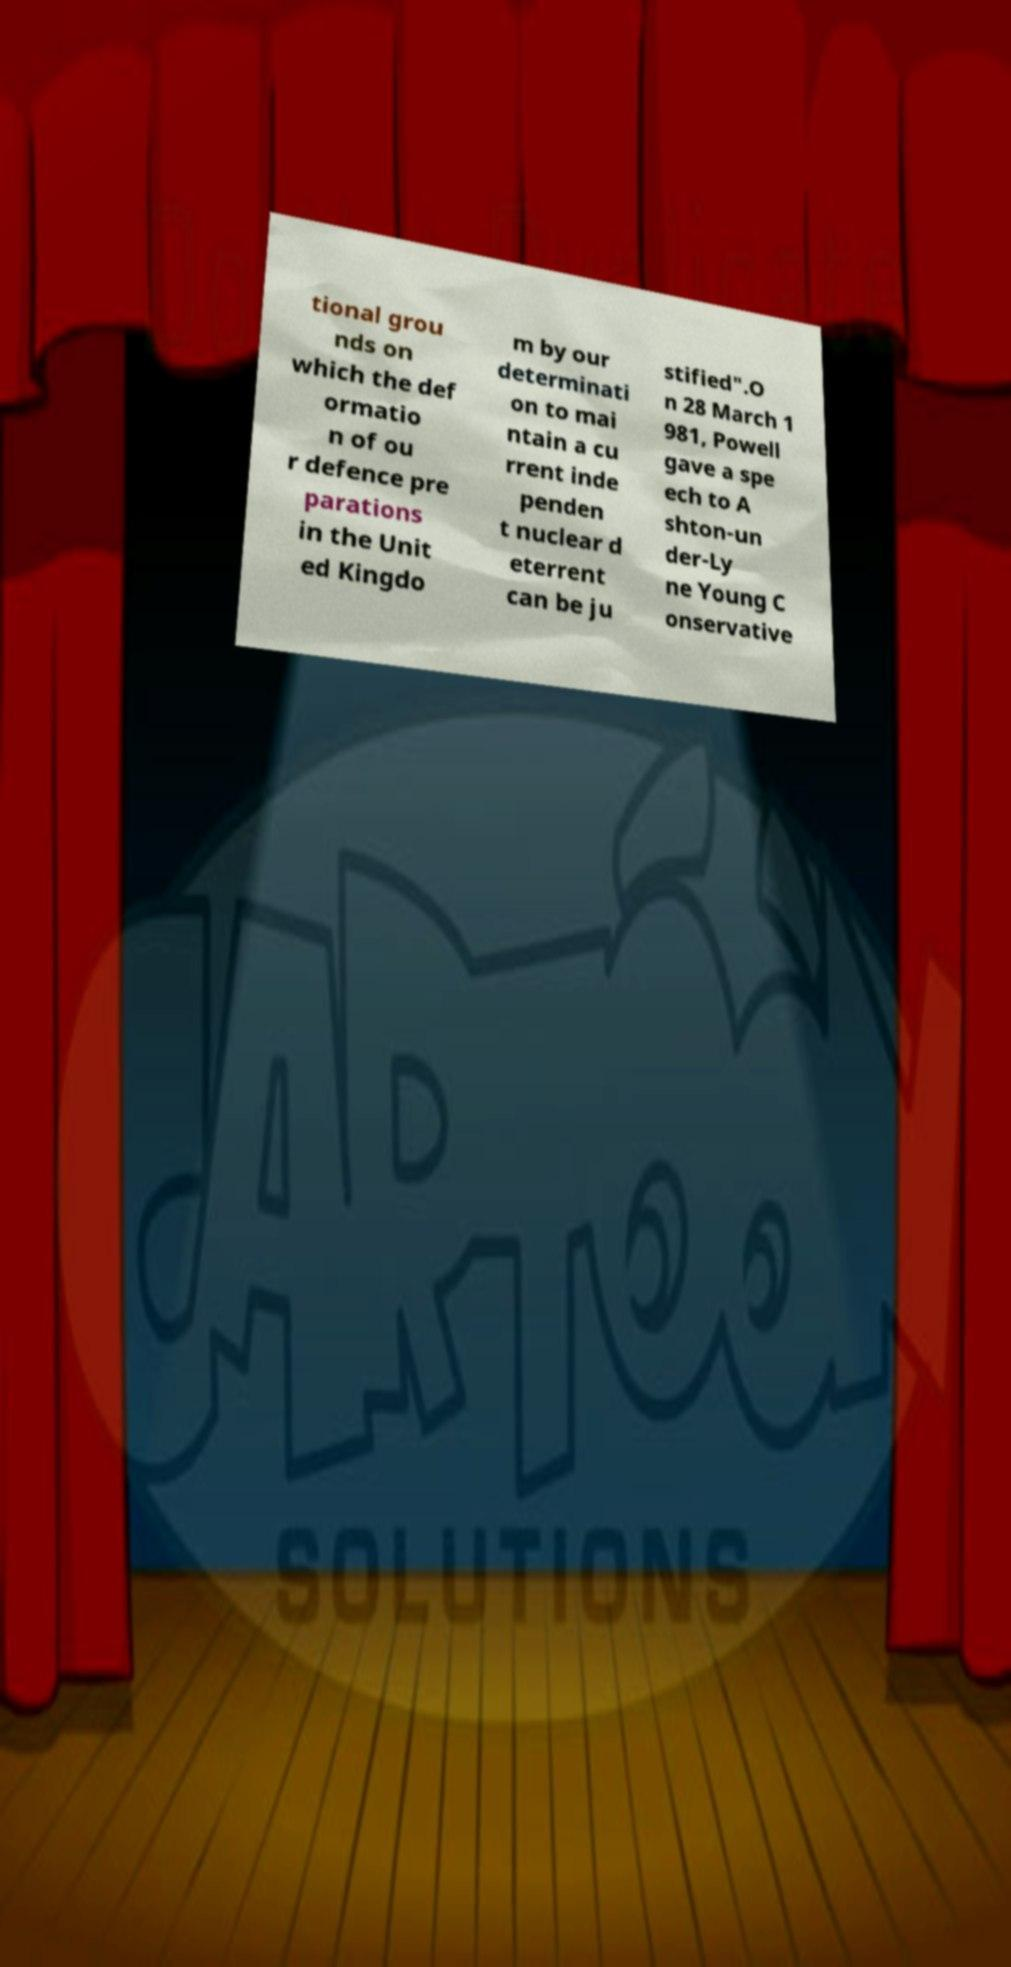Can you accurately transcribe the text from the provided image for me? tional grou nds on which the def ormatio n of ou r defence pre parations in the Unit ed Kingdo m by our determinati on to mai ntain a cu rrent inde penden t nuclear d eterrent can be ju stified".O n 28 March 1 981, Powell gave a spe ech to A shton-un der-Ly ne Young C onservative 